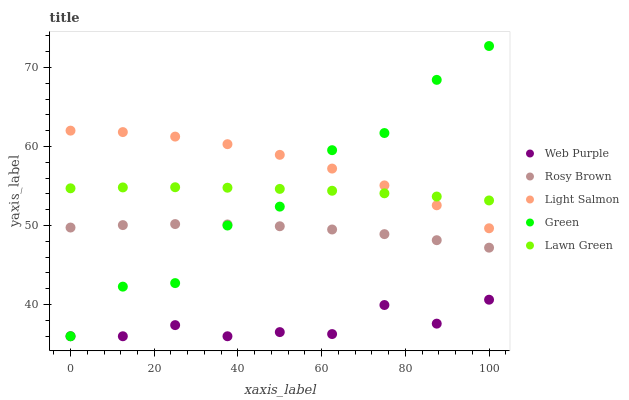Does Web Purple have the minimum area under the curve?
Answer yes or no. Yes. Does Light Salmon have the maximum area under the curve?
Answer yes or no. Yes. Does Rosy Brown have the minimum area under the curve?
Answer yes or no. No. Does Rosy Brown have the maximum area under the curve?
Answer yes or no. No. Is Lawn Green the smoothest?
Answer yes or no. Yes. Is Green the roughest?
Answer yes or no. Yes. Is Web Purple the smoothest?
Answer yes or no. No. Is Web Purple the roughest?
Answer yes or no. No. Does Web Purple have the lowest value?
Answer yes or no. Yes. Does Rosy Brown have the lowest value?
Answer yes or no. No. Does Green have the highest value?
Answer yes or no. Yes. Does Rosy Brown have the highest value?
Answer yes or no. No. Is Rosy Brown less than Lawn Green?
Answer yes or no. Yes. Is Light Salmon greater than Rosy Brown?
Answer yes or no. Yes. Does Green intersect Rosy Brown?
Answer yes or no. Yes. Is Green less than Rosy Brown?
Answer yes or no. No. Is Green greater than Rosy Brown?
Answer yes or no. No. Does Rosy Brown intersect Lawn Green?
Answer yes or no. No. 